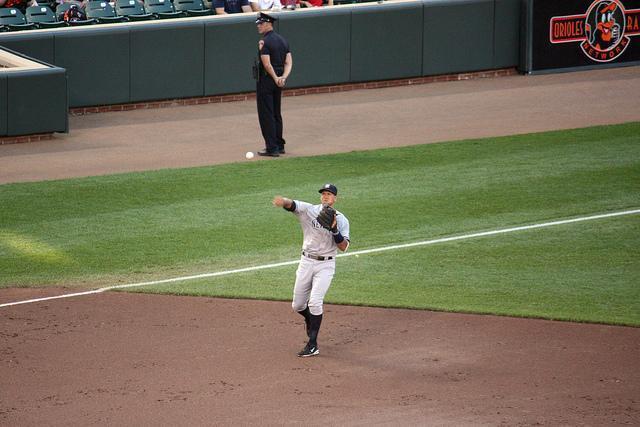What profession is the man facing the crowd?
Answer the question by selecting the correct answer among the 4 following choices.
Options: Cook, police officer, janitor, librarian. Police officer. 